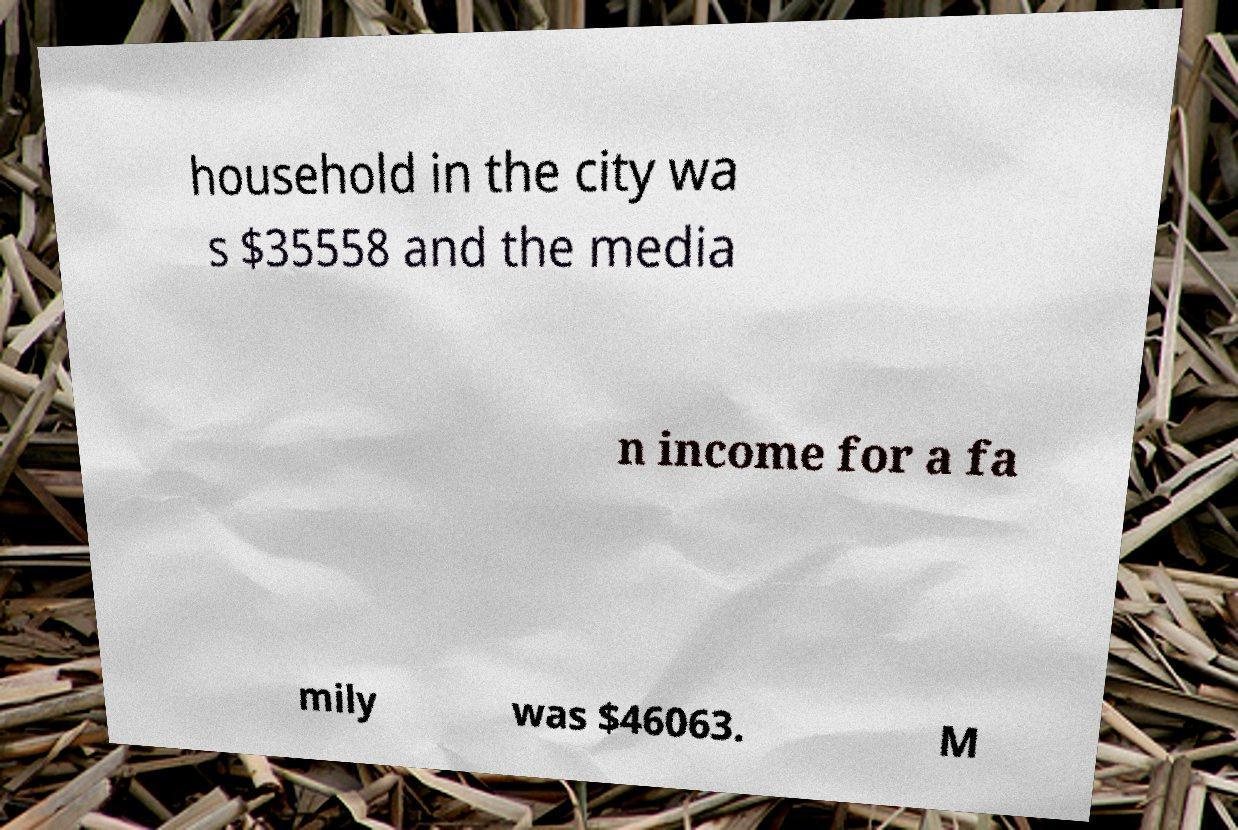Could you assist in decoding the text presented in this image and type it out clearly? household in the city wa s $35558 and the media n income for a fa mily was $46063. M 